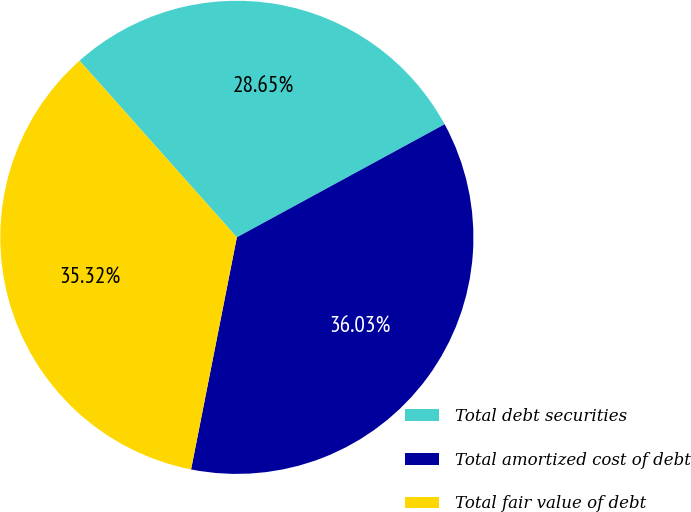Convert chart to OTSL. <chart><loc_0><loc_0><loc_500><loc_500><pie_chart><fcel>Total debt securities<fcel>Total amortized cost of debt<fcel>Total fair value of debt<nl><fcel>28.65%<fcel>36.03%<fcel>35.32%<nl></chart> 